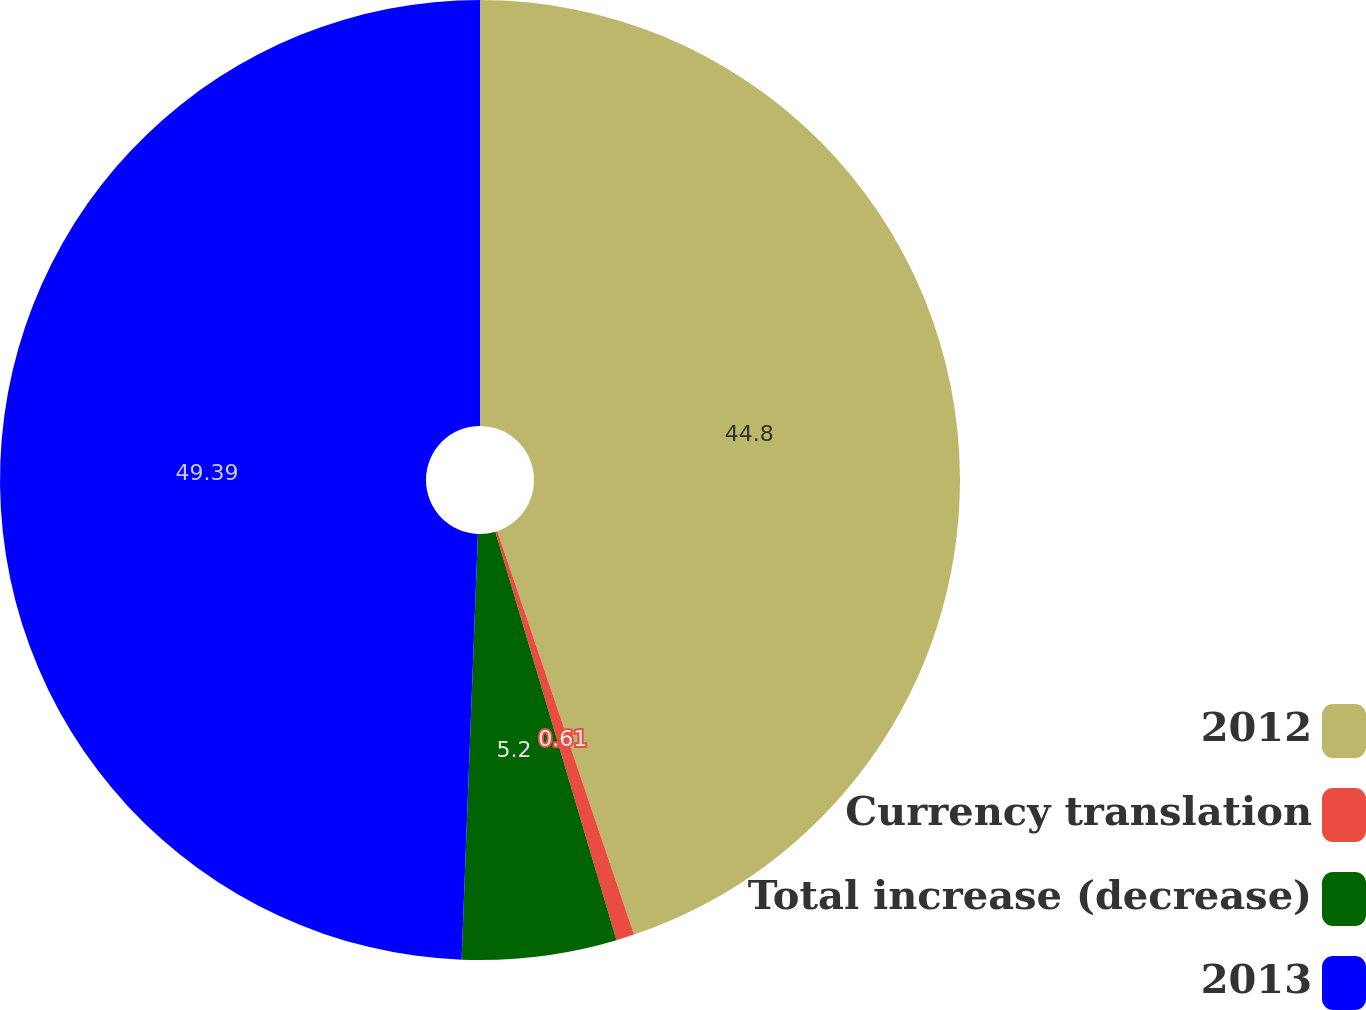Convert chart. <chart><loc_0><loc_0><loc_500><loc_500><pie_chart><fcel>2012<fcel>Currency translation<fcel>Total increase (decrease)<fcel>2013<nl><fcel>44.8%<fcel>0.61%<fcel>5.2%<fcel>49.39%<nl></chart> 